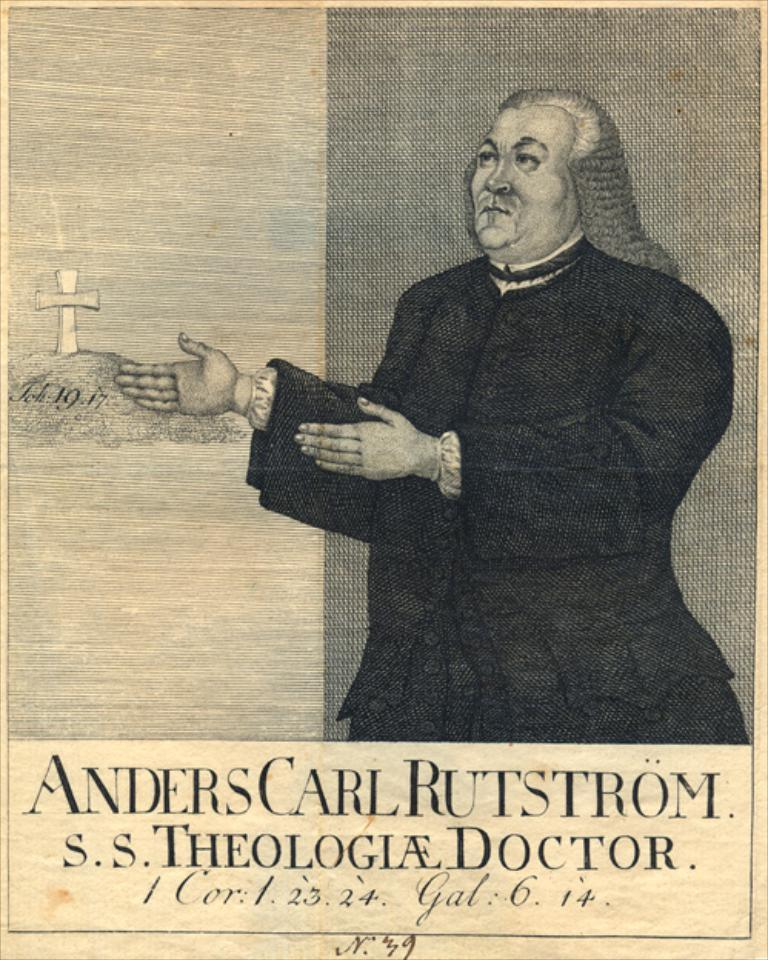What is depicted in the image? There is a drawing of a man in the image. What other object can be seen in the image? There is a cross in the image. Is there any text present in the image? Yes, there is text written at the bottom of the image. What type of instrument is the man playing in the image? There is no instrument present in the image; it only features a drawing of a man and a cross. How many brothers does the man in the image have? There is no information about the man's family in the image, so it cannot be determined how many brothers he has. 